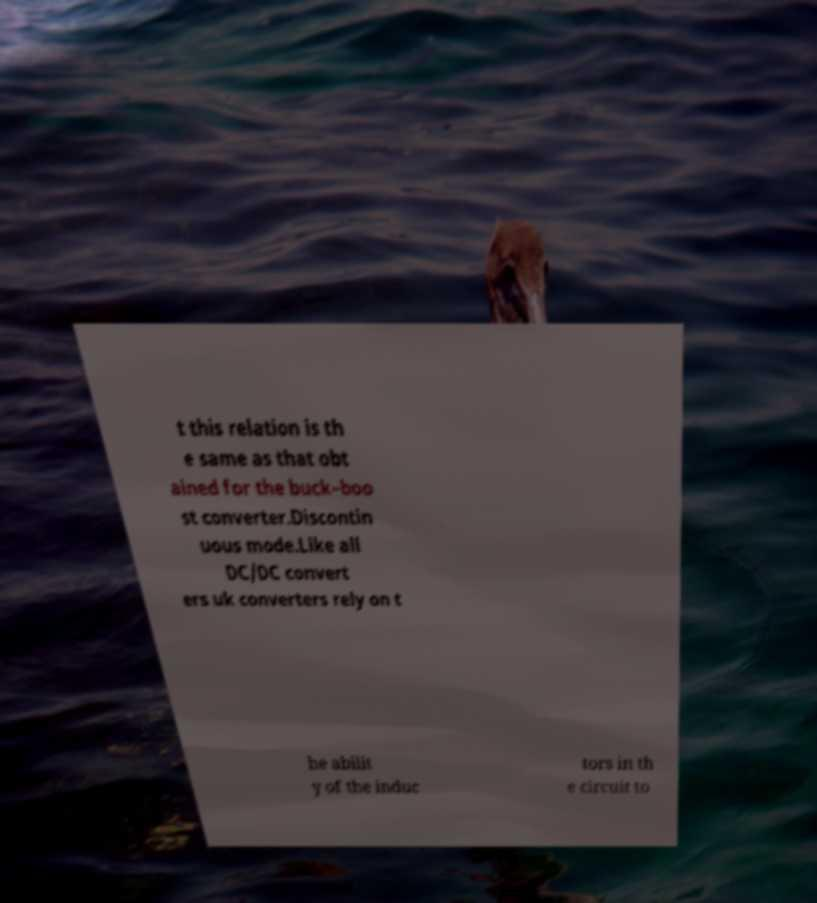I need the written content from this picture converted into text. Can you do that? t this relation is th e same as that obt ained for the buck–boo st converter.Discontin uous mode.Like all DC/DC convert ers uk converters rely on t he abilit y of the induc tors in th e circuit to 